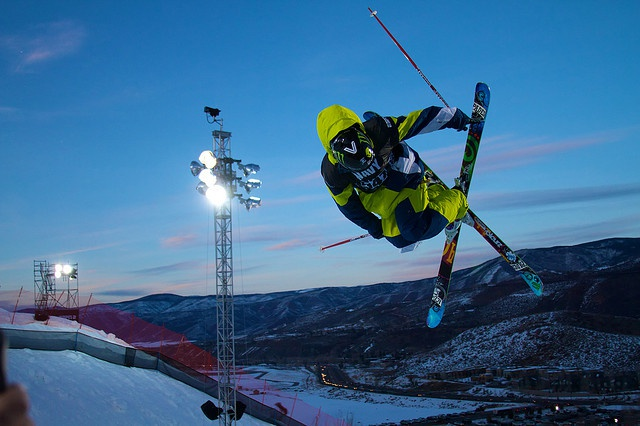Describe the objects in this image and their specific colors. I can see people in blue, black, olive, and darkgreen tones and skis in blue, black, teal, and navy tones in this image. 